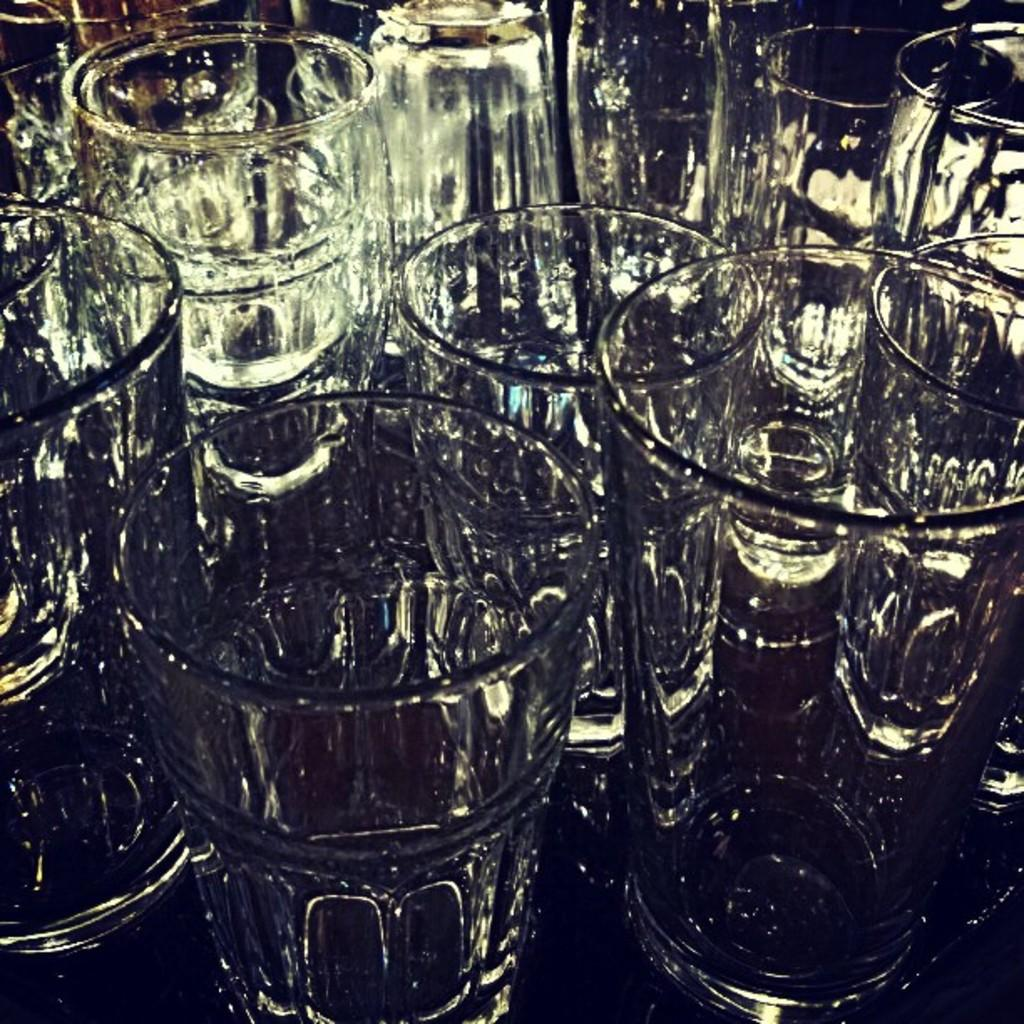What objects are present in the image that are typically used for consuming beverages? There are drinking glasses in the image. What type of bears can be seen interacting with the drinking glasses in the image? There are no bears present in the image, and therefore no such interaction can be observed. 